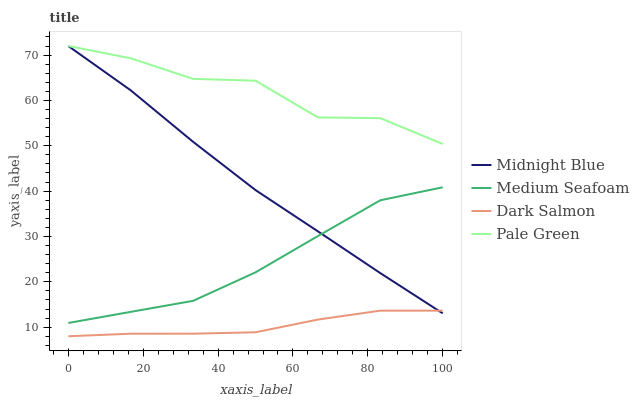Does Dark Salmon have the minimum area under the curve?
Answer yes or no. Yes. Does Pale Green have the maximum area under the curve?
Answer yes or no. Yes. Does Midnight Blue have the minimum area under the curve?
Answer yes or no. No. Does Midnight Blue have the maximum area under the curve?
Answer yes or no. No. Is Midnight Blue the smoothest?
Answer yes or no. Yes. Is Pale Green the roughest?
Answer yes or no. Yes. Is Dark Salmon the smoothest?
Answer yes or no. No. Is Dark Salmon the roughest?
Answer yes or no. No. Does Dark Salmon have the lowest value?
Answer yes or no. Yes. Does Midnight Blue have the lowest value?
Answer yes or no. No. Does Midnight Blue have the highest value?
Answer yes or no. Yes. Does Dark Salmon have the highest value?
Answer yes or no. No. Is Dark Salmon less than Medium Seafoam?
Answer yes or no. Yes. Is Pale Green greater than Dark Salmon?
Answer yes or no. Yes. Does Midnight Blue intersect Pale Green?
Answer yes or no. Yes. Is Midnight Blue less than Pale Green?
Answer yes or no. No. Is Midnight Blue greater than Pale Green?
Answer yes or no. No. Does Dark Salmon intersect Medium Seafoam?
Answer yes or no. No. 